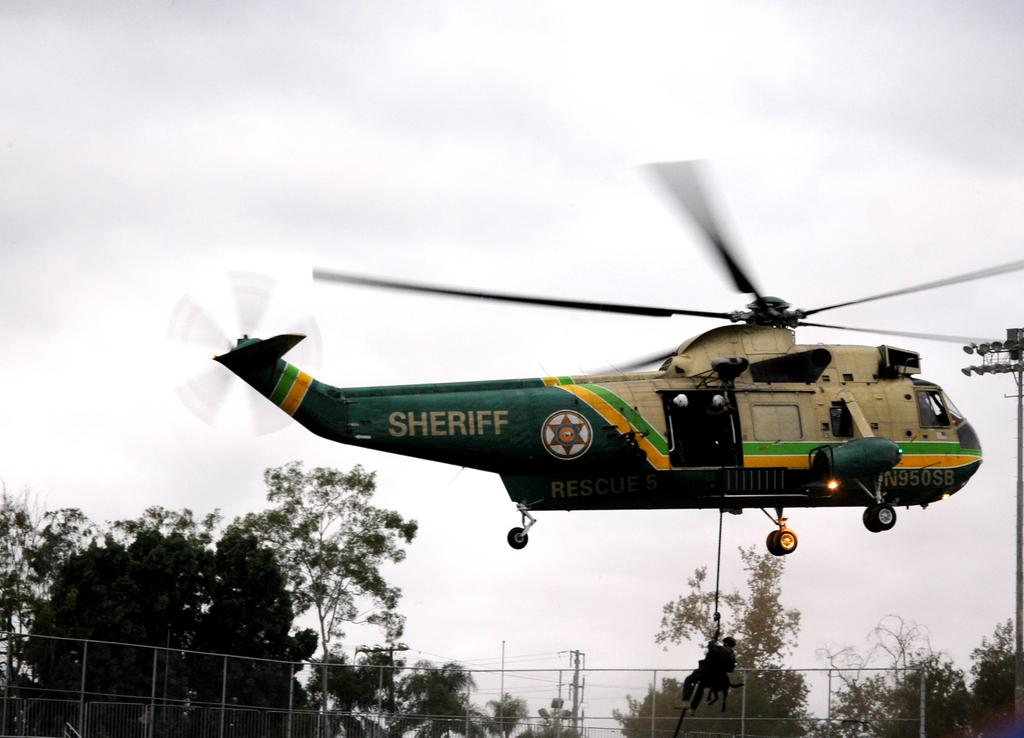<image>
Relay a brief, clear account of the picture shown. a Sheriff helicopter up in the sky with person hanging from it 